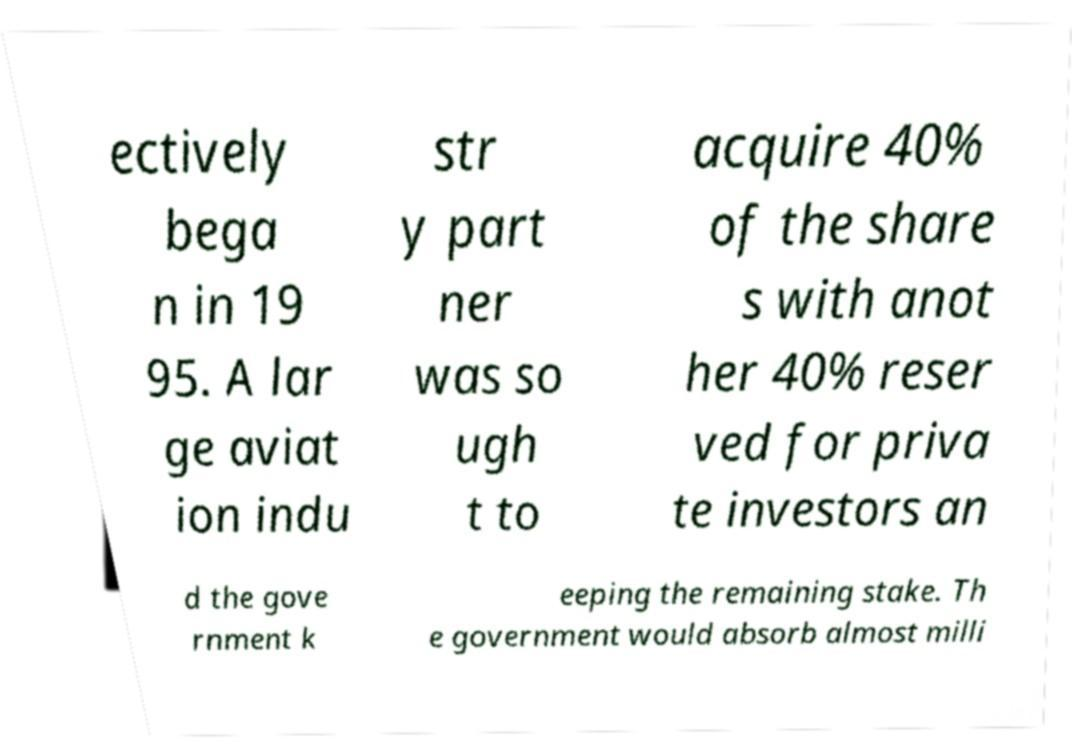For documentation purposes, I need the text within this image transcribed. Could you provide that? ectively bega n in 19 95. A lar ge aviat ion indu str y part ner was so ugh t to acquire 40% of the share s with anot her 40% reser ved for priva te investors an d the gove rnment k eeping the remaining stake. Th e government would absorb almost milli 